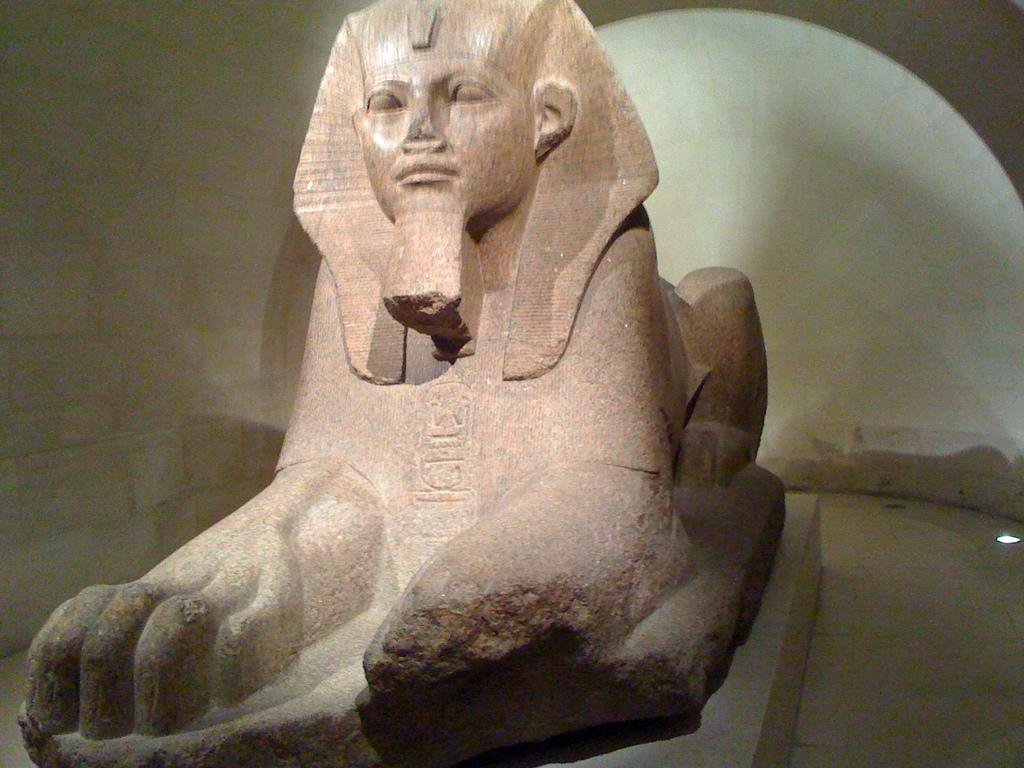What is the main subject of the image? There is a statue in the image. Where is the statue located? The statue is on the floor. What can be seen in the background of the image? There is a wall in the background of the image. What type of wound can be seen on the statue in the image? There is no wound visible on the statue in the image. What type of vessel is being used to transport the statue in the image? There is no vessel present in the image, and the statue is on the floor. 